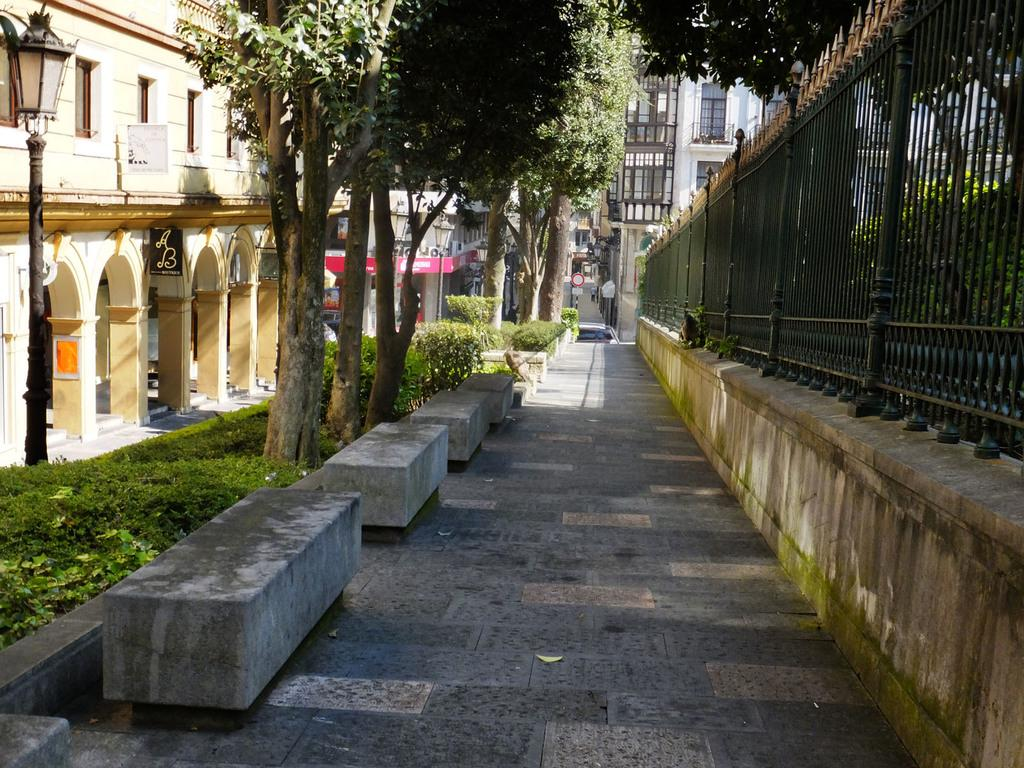What type of natural elements can be seen in the image? There are plants and trees visible in the image. What type of man-made structures can be seen in the image? There are pillars, buildings, poles, walls, railing, and floors visible in the image. What type of platforms are present in the image? There are stone platforms visible in the image. What type of signage is present in the image? There are boards visible in the image. Can you tell me where the cemetery is located in the image? There is no cemetery present in the image. What type of parent is depicted in the image? There is no parent depicted in the image. 